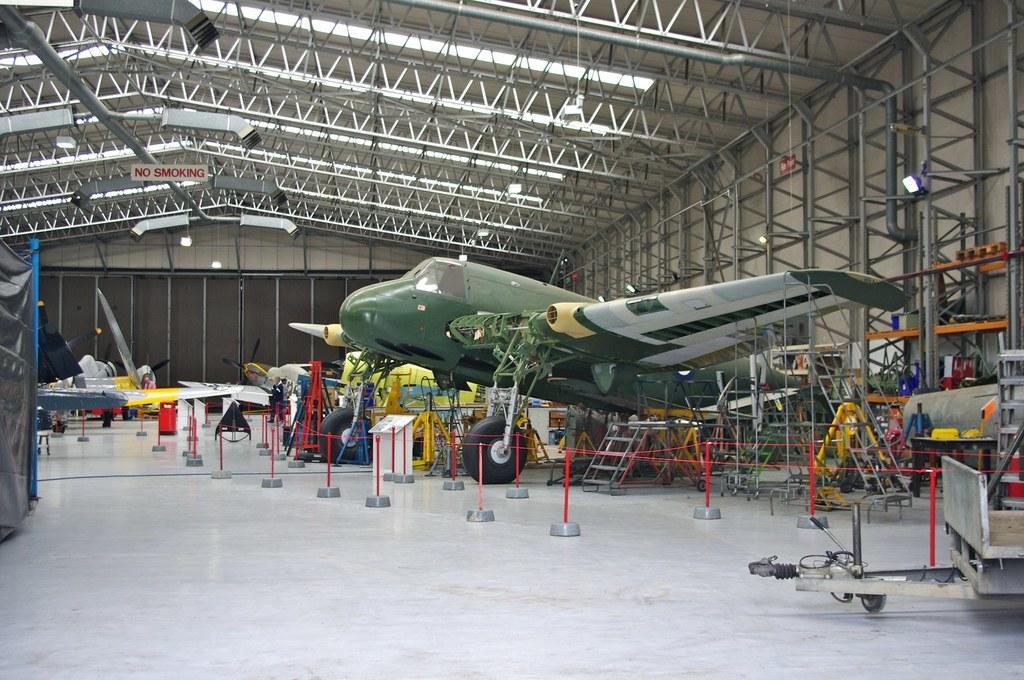<image>
Create a compact narrative representing the image presented. A large open hanger with planes inside has a sign hanging from the ceiling that says No Smoking. 